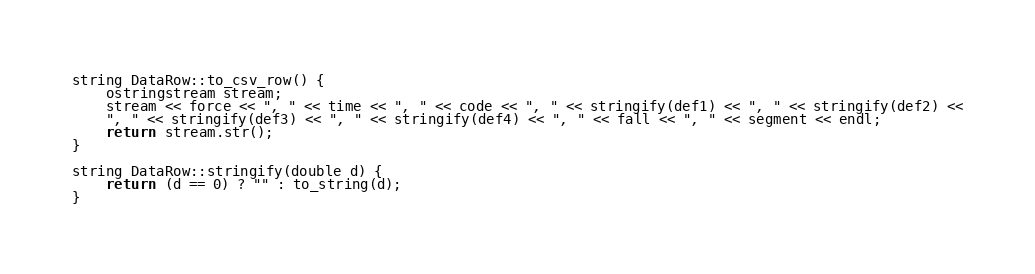<code> <loc_0><loc_0><loc_500><loc_500><_C++_>
string DataRow::to_csv_row() {
    ostringstream stream;
    stream << force << ", " << time << ", " << code << ", " << stringify(def1) << ", " << stringify(def2) <<
    ", " << stringify(def3) << ", " << stringify(def4) << ", " << fall << ", " << segment << endl;
    return stream.str();
}

string DataRow::stringify(double d) {
    return (d == 0) ? "" : to_string(d);
}
</code> 